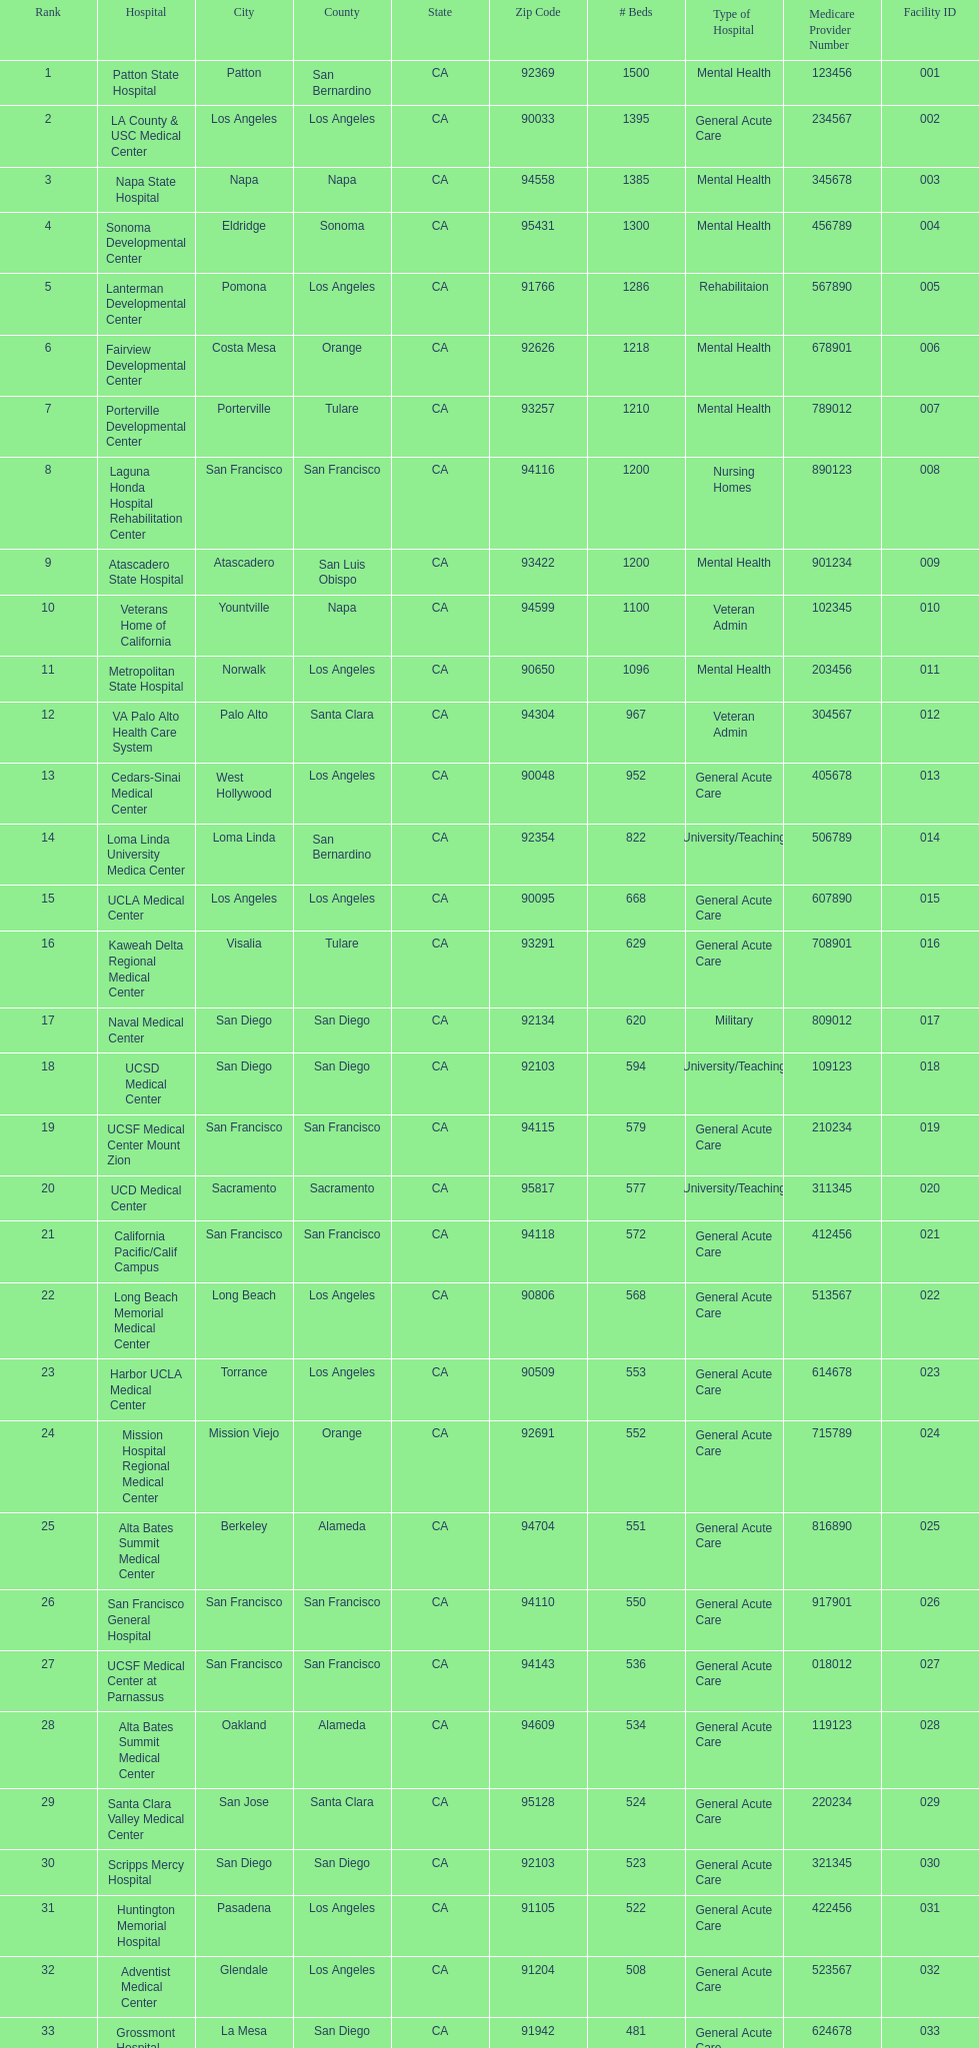How many hospital's have at least 600 beds? 17. 